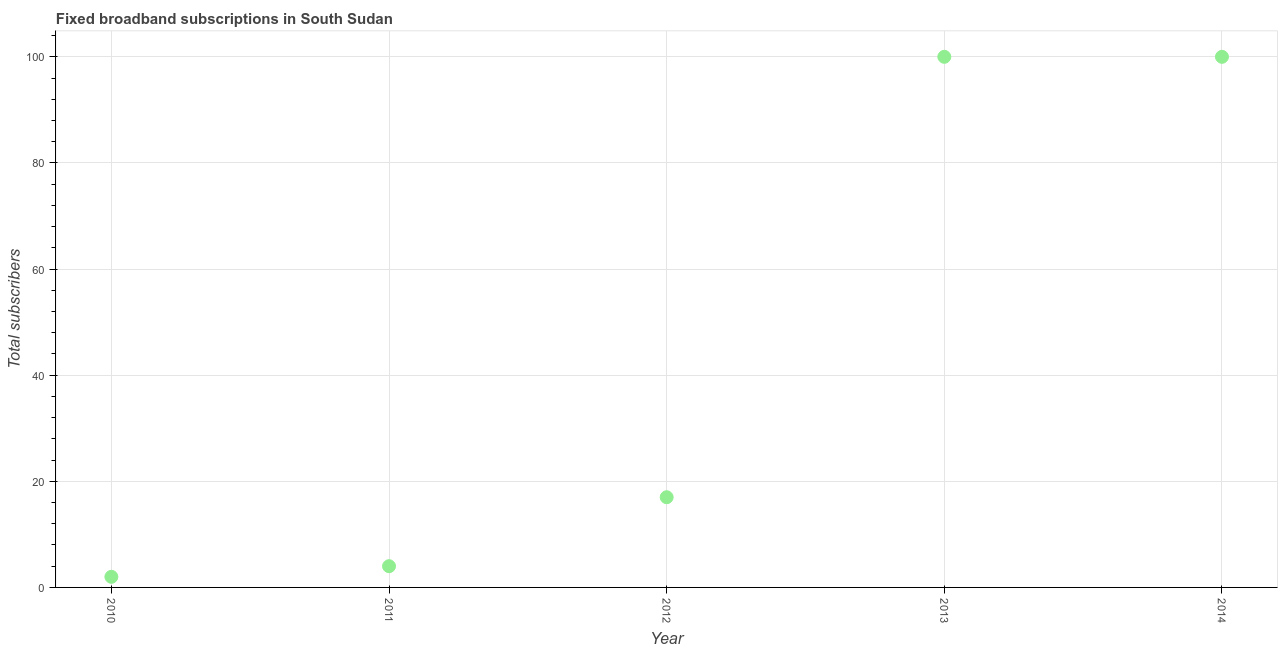What is the total number of fixed broadband subscriptions in 2012?
Provide a succinct answer. 17. Across all years, what is the maximum total number of fixed broadband subscriptions?
Your response must be concise. 100. Across all years, what is the minimum total number of fixed broadband subscriptions?
Your answer should be very brief. 2. In which year was the total number of fixed broadband subscriptions minimum?
Make the answer very short. 2010. What is the sum of the total number of fixed broadband subscriptions?
Provide a short and direct response. 223. What is the difference between the total number of fixed broadband subscriptions in 2013 and 2014?
Your response must be concise. 0. What is the average total number of fixed broadband subscriptions per year?
Your answer should be very brief. 44.6. What is the ratio of the total number of fixed broadband subscriptions in 2010 to that in 2014?
Provide a succinct answer. 0.02. Is the total number of fixed broadband subscriptions in 2011 less than that in 2014?
Give a very brief answer. Yes. What is the difference between the highest and the second highest total number of fixed broadband subscriptions?
Your answer should be very brief. 0. Is the sum of the total number of fixed broadband subscriptions in 2011 and 2014 greater than the maximum total number of fixed broadband subscriptions across all years?
Your answer should be very brief. Yes. What is the difference between the highest and the lowest total number of fixed broadband subscriptions?
Make the answer very short. 98. How many years are there in the graph?
Keep it short and to the point. 5. What is the difference between two consecutive major ticks on the Y-axis?
Make the answer very short. 20. Does the graph contain any zero values?
Make the answer very short. No. Does the graph contain grids?
Keep it short and to the point. Yes. What is the title of the graph?
Your response must be concise. Fixed broadband subscriptions in South Sudan. What is the label or title of the X-axis?
Your response must be concise. Year. What is the label or title of the Y-axis?
Offer a very short reply. Total subscribers. What is the Total subscribers in 2010?
Keep it short and to the point. 2. What is the Total subscribers in 2012?
Make the answer very short. 17. What is the Total subscribers in 2013?
Your response must be concise. 100. What is the Total subscribers in 2014?
Your answer should be very brief. 100. What is the difference between the Total subscribers in 2010 and 2011?
Make the answer very short. -2. What is the difference between the Total subscribers in 2010 and 2012?
Offer a terse response. -15. What is the difference between the Total subscribers in 2010 and 2013?
Keep it short and to the point. -98. What is the difference between the Total subscribers in 2010 and 2014?
Your answer should be very brief. -98. What is the difference between the Total subscribers in 2011 and 2013?
Make the answer very short. -96. What is the difference between the Total subscribers in 2011 and 2014?
Your answer should be compact. -96. What is the difference between the Total subscribers in 2012 and 2013?
Give a very brief answer. -83. What is the difference between the Total subscribers in 2012 and 2014?
Keep it short and to the point. -83. What is the ratio of the Total subscribers in 2010 to that in 2012?
Offer a very short reply. 0.12. What is the ratio of the Total subscribers in 2010 to that in 2013?
Your response must be concise. 0.02. What is the ratio of the Total subscribers in 2011 to that in 2012?
Offer a very short reply. 0.23. What is the ratio of the Total subscribers in 2011 to that in 2013?
Offer a terse response. 0.04. What is the ratio of the Total subscribers in 2011 to that in 2014?
Provide a short and direct response. 0.04. What is the ratio of the Total subscribers in 2012 to that in 2013?
Offer a terse response. 0.17. What is the ratio of the Total subscribers in 2012 to that in 2014?
Provide a succinct answer. 0.17. What is the ratio of the Total subscribers in 2013 to that in 2014?
Give a very brief answer. 1. 